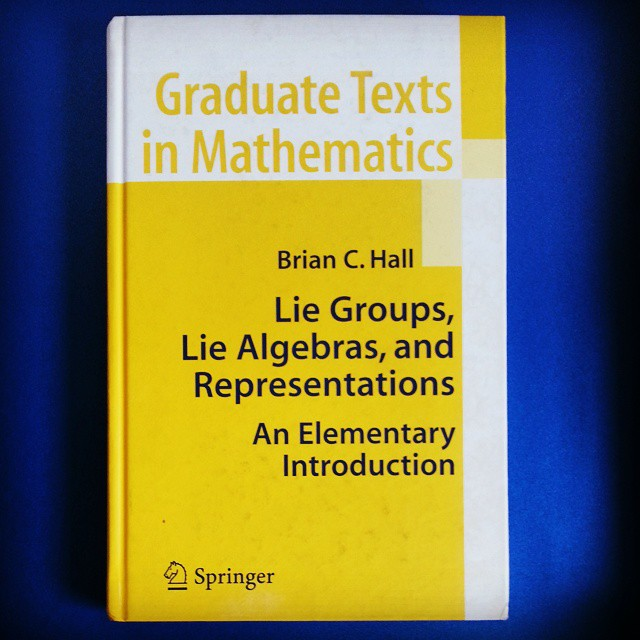Can you explain what Lie groups are in simple terms? Sure! Imagine a Lie group as a collection of movements that can be smoothly combined and reversed. For example, think of all possible rotations around a sphere. Each rotation is a part of the group, and combining two rotations gives another rotation. These structures help us understand continuous transformations and have applications in physics, where they describe symmetries of physical systems. How are Lie algebras different from Lie groups? Lie algebras can be thought of as the framework that underpins Lie groups but on a smaller, simplified scale. While a Lie group includes all possible transformations, a Lie algebra focuses on the 'infinitesimal' transformations – the smallest possible changes and how they relate. If Lie groups are like a big map of directions, Lie algebras are the compass and rulers that let you measure the tiniest steps and turns on that map. 